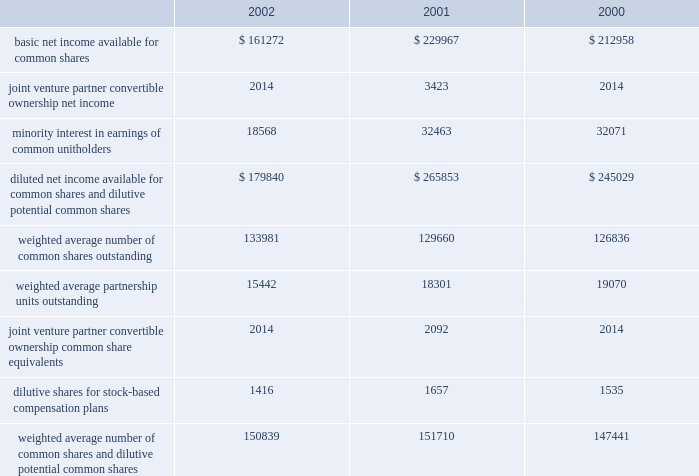D u k e r e a l t y c o r p o r a t i o n 2 8 2 0 0 2 a n n u a l r e p o r t notes to consolidated financial statements the company recognizes income on long-term construction contracts where the company serves as a general contractor on the percentage of completion method .
Using this method , profits are recorded on the basis of the company 2019s estimates of the percentage of completion of individual contracts , commencing when progress reaches a point where experience is sufficient to estimate final results with reasonable accuracy .
That portion of the estimated earnings is accrued on the basis of the company 2019s estimates of the percentage of completion based on contract expenditures incurred and work performed .
Property sales gains from sales of depreciated property are recognized in accordance with statement of financial accounting standards ( 201csfas 201d ) no .
66 , and are included in earnings from sales of land and depreciable property dispositions , net of impairment adjustment , in the statement of operations if identified as held for sale prior to adoption of sfas 144 and in discontinued operations if identified as held for sale after adoption of sfas 144 .
Gains or losses from the sale of property which is considered held for sale in dclp are recognized in accordance with sfas 66 and are included in construction management and development activity income in the statement of operations .
Net income per common share basic net income per common share is computed by dividing net income available for common shares by the weighted average number of common shares outstanding for the period .
Diluted net income per share is computed by dividing the sum of net income available for common shares and minority interest in earnings of unitholders , by the sum of the weighted average number of common shares and units outstanding and dilutive potential common shares for the period .
The table reconciles the components of basic and diluted net income per share ( in thousands ) : the series d convertible preferred stock and the series g convertible preferred limited partner units were anti-dilutive for the years ended december 31 , 2002 , 2001 and 2000 ; therefore , no conversion to common shares is included in weighted dilutive potential common shares .
In september 2002 , the company redeemed the series g convertible preferred units at their par value of $ 35.0 million .
A joint venture partner in one of the company 2019s unconsolidated companies has the option to convert a portion of its ownership to company common shares ( see discussion in investments in unconsolidated companies section ) .
The effect of the option on earnings per share was dilutive for the year ended december 31 , 2001 ; therefore , conversion to common shares is included in weighted dilutive potential common shares .
Federal income taxes the company has elected to be taxed as a real estate investment trust ( 201creit 201d ) under the internal revenue code .
To qualify as a reit , the company must meet a number of organizational and operational requirements , including a requirement that it currently distribute at least 90% ( 90 % ) of its taxable income to its stockholders .
Management intends to continue to adhere to these requirements and to maintain the company 2019s reit status .
As a reit , the company is entitled to a tax deduction for some or all of the dividends it pays to its shareholders .
Accordingly , the company generally will not be subject to federal income taxes as long as it distributes an amount equal to or in excess of its taxable income currently to its stockholders .
A reit generally is subject to federal income taxes on any taxable income that is not currently distributed to its shareholders .
If the company fails to qualify as a reit in any taxable year , it will be subject to federal income taxes and may not be able to qualify as a reit for four subsequent taxable years .
Reit qualification reduces , but does not eliminate , the amount of state and local taxes paid by the company .
In addition , the company 2019s financial statements include the operations of taxable corporate subsidiaries that are not entitled to a dividends paid deduction and are subject to corporate federal , state and local income taxes .
As a reit , the company may also be subject to certain federal excise taxes if it engages in certain types of transactions. .

What was the average basic net income available for common shares from 2000 to 2002? 
Computations: (((161272 + 229967) + 212958) / 3)
Answer: 201399.0. 